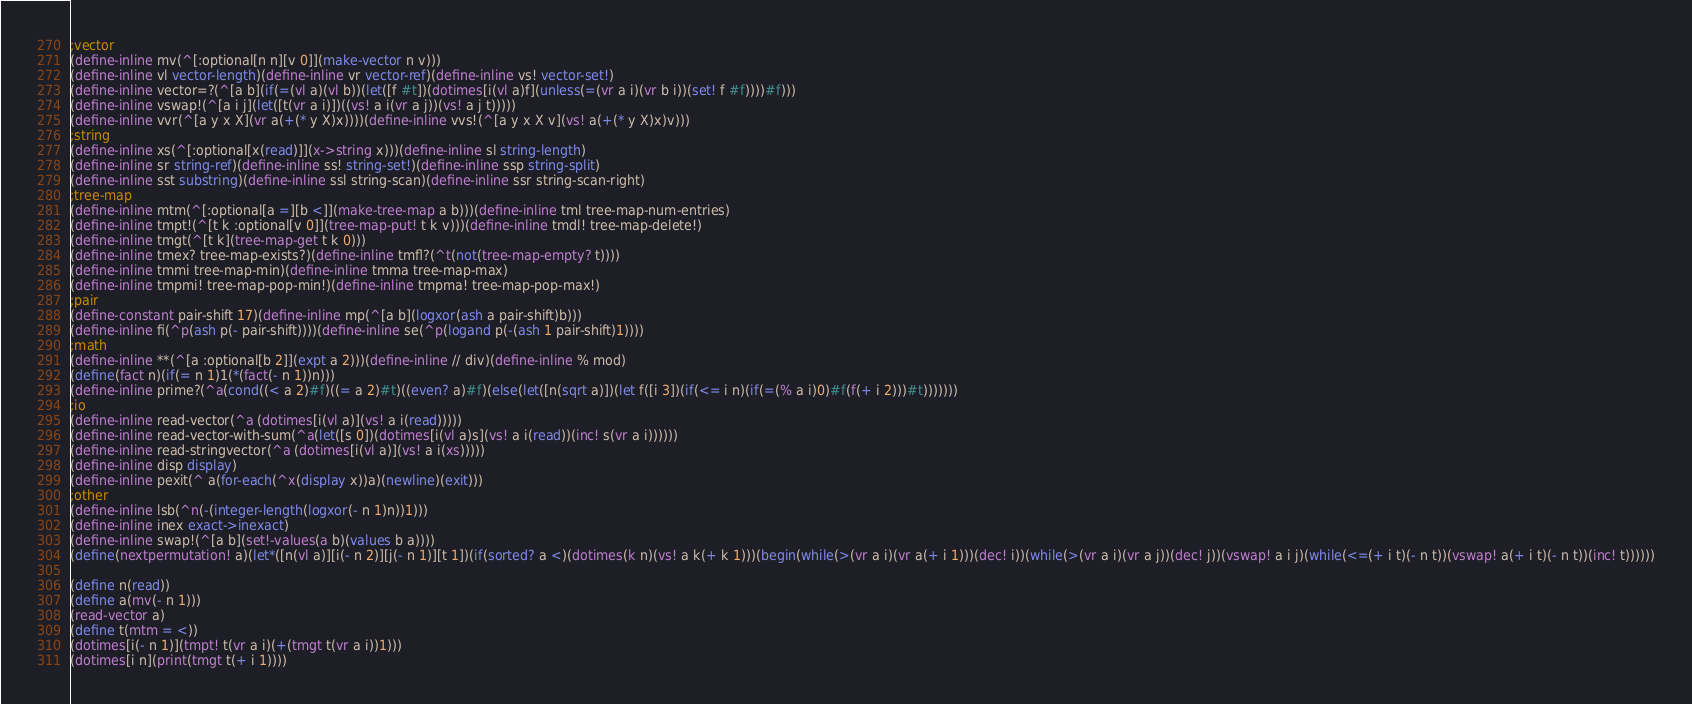Convert code to text. <code><loc_0><loc_0><loc_500><loc_500><_Scheme_>;vector
(define-inline mv(^[:optional[n n][v 0]](make-vector n v)))
(define-inline vl vector-length)(define-inline vr vector-ref)(define-inline vs! vector-set!)
(define-inline vector=?(^[a b](if(=(vl a)(vl b))(let([f #t])(dotimes[i(vl a)f](unless(=(vr a i)(vr b i))(set! f #f))))#f)))
(define-inline vswap!(^[a i j](let([t(vr a i)])((vs! a i(vr a j))(vs! a j t)))))
(define-inline vvr(^[a y x X](vr a(+(* y X)x))))(define-inline vvs!(^[a y x X v](vs! a(+(* y X)x)v)))
;string
(define-inline xs(^[:optional[x(read)]](x->string x)))(define-inline sl string-length)
(define-inline sr string-ref)(define-inline ss! string-set!)(define-inline ssp string-split)
(define-inline sst substring)(define-inline ssl string-scan)(define-inline ssr string-scan-right)
;tree-map
(define-inline mtm(^[:optional[a =][b <]](make-tree-map a b)))(define-inline tml tree-map-num-entries)
(define-inline tmpt!(^[t k :optional[v 0]](tree-map-put! t k v)))(define-inline tmdl! tree-map-delete!)
(define-inline tmgt(^[t k](tree-map-get t k 0)))
(define-inline tmex? tree-map-exists?)(define-inline tmfl?(^t(not(tree-map-empty? t))))
(define-inline tmmi tree-map-min)(define-inline tmma tree-map-max)
(define-inline tmpmi! tree-map-pop-min!)(define-inline tmpma! tree-map-pop-max!)
;pair
(define-constant pair-shift 17)(define-inline mp(^[a b](logxor(ash a pair-shift)b)))
(define-inline fi(^p(ash p(- pair-shift))))(define-inline se(^p(logand p(-(ash 1 pair-shift)1))))
;math
(define-inline **(^[a :optional[b 2]](expt a 2)))(define-inline // div)(define-inline % mod)
(define(fact n)(if(= n 1)1(*(fact(- n 1))n)))
(define-inline prime?(^a(cond((< a 2)#f)((= a 2)#t)((even? a)#f)(else(let([n(sqrt a)])(let f([i 3])(if(<= i n)(if(=(% a i)0)#f(f(+ i 2)))#t)))))))
;io
(define-inline read-vector(^a (dotimes[i(vl a)](vs! a i(read)))))
(define-inline read-vector-with-sum(^a(let([s 0])(dotimes[i(vl a)s](vs! a i(read))(inc! s(vr a i))))))
(define-inline read-stringvector(^a (dotimes[i(vl a)](vs! a i(xs)))))
(define-inline disp display)
(define-inline pexit(^ a(for-each(^x(display x))a)(newline)(exit)))
;other
(define-inline lsb(^n(-(integer-length(logxor(- n 1)n))1)))
(define-inline inex exact->inexact)
(define-inline swap!(^[a b](set!-values(a b)(values b a))))
(define(nextpermutation! a)(let*([n(vl a)][i(- n 2)][j(- n 1)][t 1])(if(sorted? a <)(dotimes(k n)(vs! a k(+ k 1)))(begin(while(>(vr a i)(vr a(+ i 1)))(dec! i))(while(>(vr a i)(vr a j))(dec! j))(vswap! a i j)(while(<=(+ i t)(- n t))(vswap! a(+ i t)(- n t))(inc! t))))))

(define n(read))
(define a(mv(- n 1)))
(read-vector a)
(define t(mtm = <))
(dotimes[i(- n 1)](tmpt! t(vr a i)(+(tmgt t(vr a i))1)))
(dotimes[i n](print(tmgt t(+ i 1))))</code> 